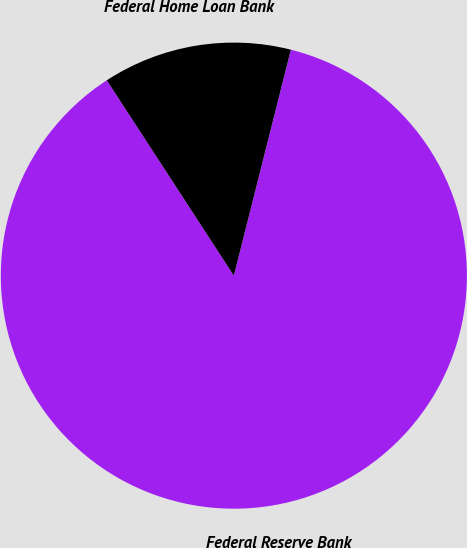Convert chart to OTSL. <chart><loc_0><loc_0><loc_500><loc_500><pie_chart><fcel>Federal Reserve Bank<fcel>Federal Home Loan Bank<nl><fcel>86.89%<fcel>13.11%<nl></chart> 